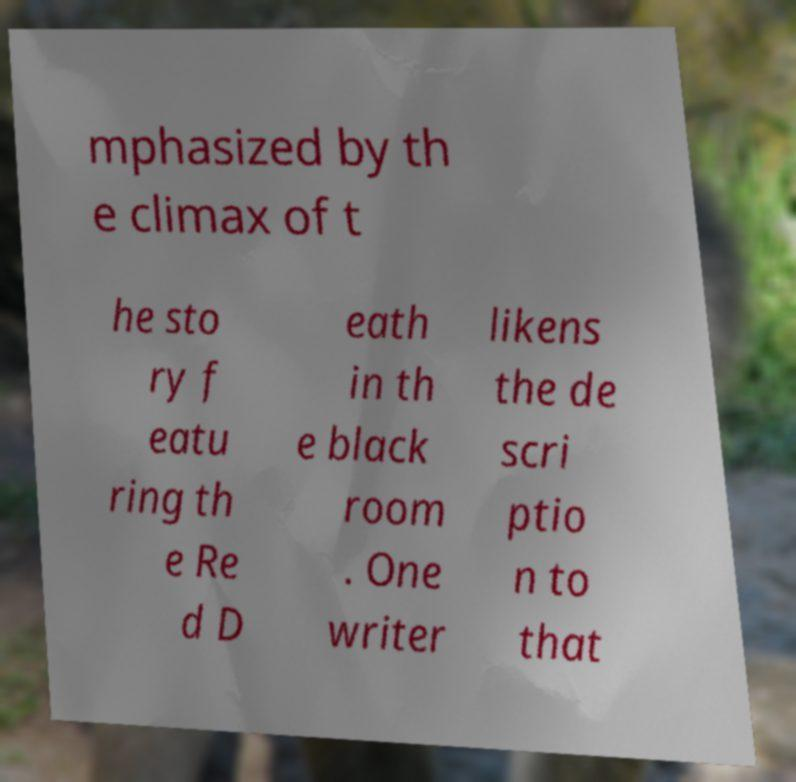For documentation purposes, I need the text within this image transcribed. Could you provide that? mphasized by th e climax of t he sto ry f eatu ring th e Re d D eath in th e black room . One writer likens the de scri ptio n to that 